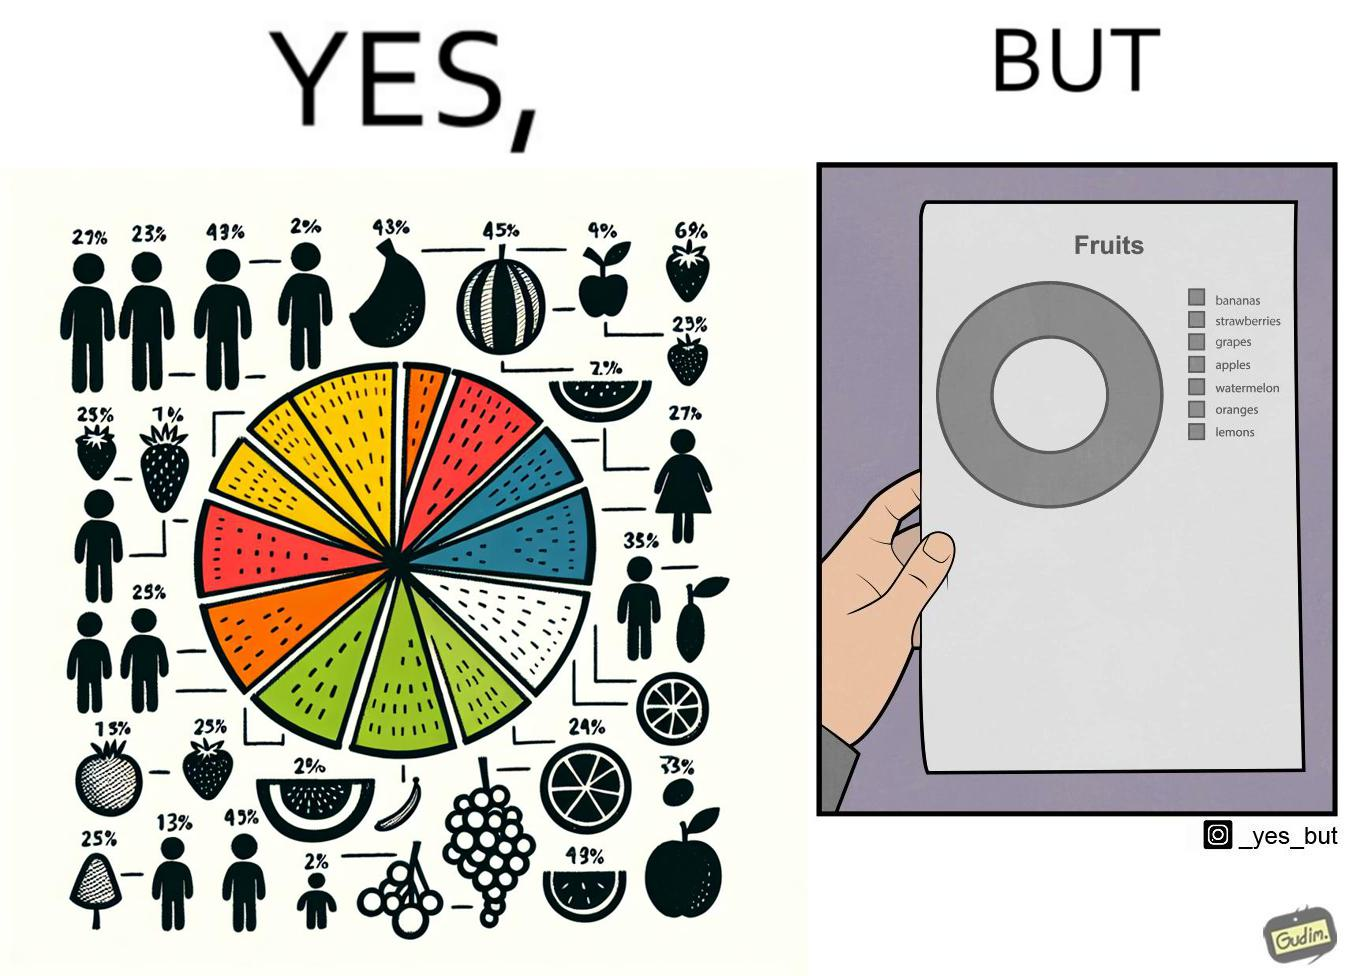What is shown in this image? This is funny because the pie chart printout is useless as you cant see any divisions on it because the  printer could not capture the different colors 